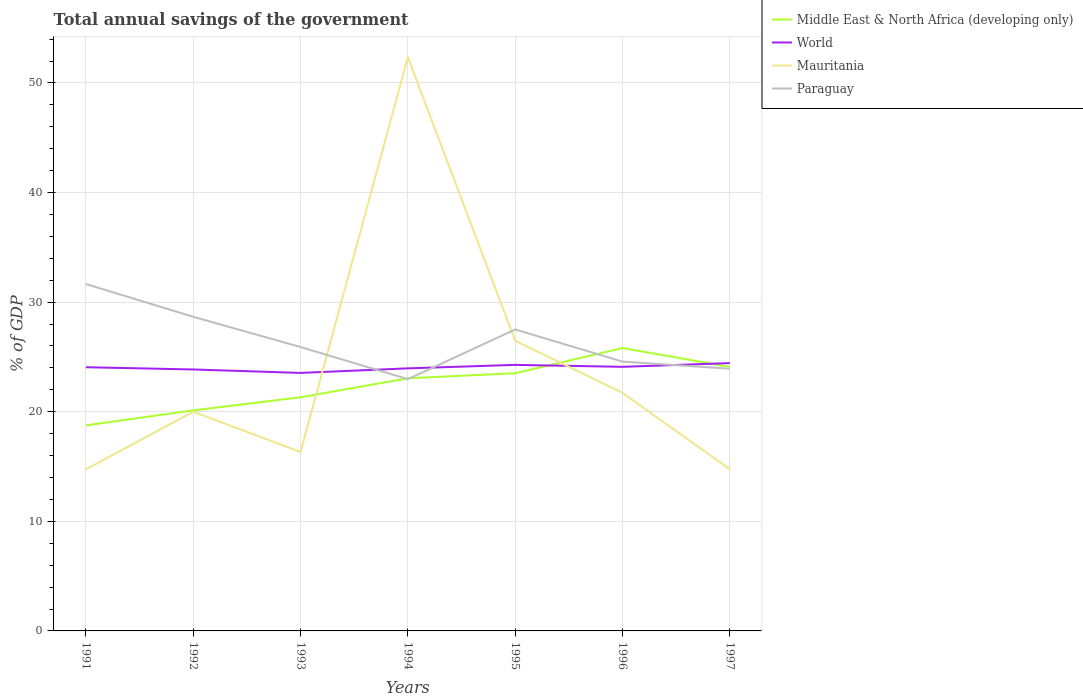Across all years, what is the maximum total annual savings of the government in Paraguay?
Offer a very short reply. 22.97. What is the total total annual savings of the government in Middle East & North Africa (developing only) in the graph?
Keep it short and to the point. -1.19. What is the difference between the highest and the second highest total annual savings of the government in Mauritania?
Provide a succinct answer. 37.61. What is the difference between the highest and the lowest total annual savings of the government in Mauritania?
Give a very brief answer. 2. How many lines are there?
Ensure brevity in your answer.  4. How many years are there in the graph?
Ensure brevity in your answer.  7. What is the difference between two consecutive major ticks on the Y-axis?
Provide a short and direct response. 10. Are the values on the major ticks of Y-axis written in scientific E-notation?
Your answer should be very brief. No. Does the graph contain grids?
Give a very brief answer. Yes. What is the title of the graph?
Your answer should be compact. Total annual savings of the government. What is the label or title of the X-axis?
Ensure brevity in your answer.  Years. What is the label or title of the Y-axis?
Make the answer very short. % of GDP. What is the % of GDP in Middle East & North Africa (developing only) in 1991?
Your answer should be very brief. 18.76. What is the % of GDP of World in 1991?
Give a very brief answer. 24.06. What is the % of GDP in Mauritania in 1991?
Ensure brevity in your answer.  14.74. What is the % of GDP of Paraguay in 1991?
Provide a short and direct response. 31.65. What is the % of GDP of Middle East & North Africa (developing only) in 1992?
Keep it short and to the point. 20.13. What is the % of GDP in World in 1992?
Provide a short and direct response. 23.86. What is the % of GDP in Mauritania in 1992?
Offer a very short reply. 20. What is the % of GDP in Paraguay in 1992?
Offer a very short reply. 28.66. What is the % of GDP in Middle East & North Africa (developing only) in 1993?
Make the answer very short. 21.32. What is the % of GDP of World in 1993?
Keep it short and to the point. 23.54. What is the % of GDP in Mauritania in 1993?
Ensure brevity in your answer.  16.33. What is the % of GDP in Paraguay in 1993?
Your response must be concise. 25.91. What is the % of GDP of Middle East & North Africa (developing only) in 1994?
Your answer should be compact. 23.05. What is the % of GDP of World in 1994?
Keep it short and to the point. 23.96. What is the % of GDP of Mauritania in 1994?
Give a very brief answer. 52.35. What is the % of GDP in Paraguay in 1994?
Make the answer very short. 22.97. What is the % of GDP of Middle East & North Africa (developing only) in 1995?
Keep it short and to the point. 23.51. What is the % of GDP of World in 1995?
Make the answer very short. 24.28. What is the % of GDP of Mauritania in 1995?
Your answer should be very brief. 26.48. What is the % of GDP of Paraguay in 1995?
Make the answer very short. 27.51. What is the % of GDP of Middle East & North Africa (developing only) in 1996?
Give a very brief answer. 25.81. What is the % of GDP of World in 1996?
Keep it short and to the point. 24.1. What is the % of GDP of Mauritania in 1996?
Give a very brief answer. 21.72. What is the % of GDP of Paraguay in 1996?
Offer a very short reply. 24.58. What is the % of GDP in Middle East & North Africa (developing only) in 1997?
Offer a terse response. 24.09. What is the % of GDP of World in 1997?
Give a very brief answer. 24.44. What is the % of GDP in Mauritania in 1997?
Your answer should be compact. 14.76. What is the % of GDP of Paraguay in 1997?
Provide a succinct answer. 23.92. Across all years, what is the maximum % of GDP of Middle East & North Africa (developing only)?
Ensure brevity in your answer.  25.81. Across all years, what is the maximum % of GDP in World?
Provide a succinct answer. 24.44. Across all years, what is the maximum % of GDP in Mauritania?
Your answer should be compact. 52.35. Across all years, what is the maximum % of GDP of Paraguay?
Your response must be concise. 31.65. Across all years, what is the minimum % of GDP in Middle East & North Africa (developing only)?
Offer a very short reply. 18.76. Across all years, what is the minimum % of GDP in World?
Offer a terse response. 23.54. Across all years, what is the minimum % of GDP in Mauritania?
Offer a terse response. 14.74. Across all years, what is the minimum % of GDP in Paraguay?
Give a very brief answer. 22.97. What is the total % of GDP in Middle East & North Africa (developing only) in the graph?
Keep it short and to the point. 156.67. What is the total % of GDP in World in the graph?
Provide a succinct answer. 168.23. What is the total % of GDP of Mauritania in the graph?
Offer a very short reply. 166.38. What is the total % of GDP of Paraguay in the graph?
Provide a short and direct response. 185.2. What is the difference between the % of GDP in Middle East & North Africa (developing only) in 1991 and that in 1992?
Provide a succinct answer. -1.37. What is the difference between the % of GDP in World in 1991 and that in 1992?
Give a very brief answer. 0.21. What is the difference between the % of GDP in Mauritania in 1991 and that in 1992?
Offer a very short reply. -5.26. What is the difference between the % of GDP in Paraguay in 1991 and that in 1992?
Make the answer very short. 2.99. What is the difference between the % of GDP of Middle East & North Africa (developing only) in 1991 and that in 1993?
Your answer should be compact. -2.56. What is the difference between the % of GDP of World in 1991 and that in 1993?
Your response must be concise. 0.52. What is the difference between the % of GDP of Mauritania in 1991 and that in 1993?
Keep it short and to the point. -1.58. What is the difference between the % of GDP in Paraguay in 1991 and that in 1993?
Make the answer very short. 5.75. What is the difference between the % of GDP in Middle East & North Africa (developing only) in 1991 and that in 1994?
Your response must be concise. -4.29. What is the difference between the % of GDP in World in 1991 and that in 1994?
Keep it short and to the point. 0.1. What is the difference between the % of GDP in Mauritania in 1991 and that in 1994?
Ensure brevity in your answer.  -37.61. What is the difference between the % of GDP of Paraguay in 1991 and that in 1994?
Offer a very short reply. 8.68. What is the difference between the % of GDP in Middle East & North Africa (developing only) in 1991 and that in 1995?
Give a very brief answer. -4.75. What is the difference between the % of GDP of World in 1991 and that in 1995?
Make the answer very short. -0.21. What is the difference between the % of GDP of Mauritania in 1991 and that in 1995?
Ensure brevity in your answer.  -11.74. What is the difference between the % of GDP of Paraguay in 1991 and that in 1995?
Your response must be concise. 4.15. What is the difference between the % of GDP in Middle East & North Africa (developing only) in 1991 and that in 1996?
Keep it short and to the point. -7.05. What is the difference between the % of GDP of World in 1991 and that in 1996?
Ensure brevity in your answer.  -0.03. What is the difference between the % of GDP in Mauritania in 1991 and that in 1996?
Your answer should be compact. -6.98. What is the difference between the % of GDP in Paraguay in 1991 and that in 1996?
Provide a succinct answer. 7.08. What is the difference between the % of GDP of Middle East & North Africa (developing only) in 1991 and that in 1997?
Give a very brief answer. -5.33. What is the difference between the % of GDP of World in 1991 and that in 1997?
Offer a terse response. -0.38. What is the difference between the % of GDP of Mauritania in 1991 and that in 1997?
Give a very brief answer. -0.01. What is the difference between the % of GDP in Paraguay in 1991 and that in 1997?
Offer a very short reply. 7.73. What is the difference between the % of GDP in Middle East & North Africa (developing only) in 1992 and that in 1993?
Ensure brevity in your answer.  -1.19. What is the difference between the % of GDP in World in 1992 and that in 1993?
Provide a short and direct response. 0.31. What is the difference between the % of GDP in Mauritania in 1992 and that in 1993?
Your answer should be compact. 3.67. What is the difference between the % of GDP of Paraguay in 1992 and that in 1993?
Make the answer very short. 2.76. What is the difference between the % of GDP in Middle East & North Africa (developing only) in 1992 and that in 1994?
Keep it short and to the point. -2.93. What is the difference between the % of GDP of World in 1992 and that in 1994?
Your answer should be very brief. -0.1. What is the difference between the % of GDP in Mauritania in 1992 and that in 1994?
Provide a succinct answer. -32.35. What is the difference between the % of GDP in Paraguay in 1992 and that in 1994?
Provide a succinct answer. 5.69. What is the difference between the % of GDP of Middle East & North Africa (developing only) in 1992 and that in 1995?
Offer a terse response. -3.39. What is the difference between the % of GDP of World in 1992 and that in 1995?
Provide a succinct answer. -0.42. What is the difference between the % of GDP of Mauritania in 1992 and that in 1995?
Your answer should be very brief. -6.48. What is the difference between the % of GDP in Paraguay in 1992 and that in 1995?
Make the answer very short. 1.16. What is the difference between the % of GDP in Middle East & North Africa (developing only) in 1992 and that in 1996?
Give a very brief answer. -5.68. What is the difference between the % of GDP in World in 1992 and that in 1996?
Keep it short and to the point. -0.24. What is the difference between the % of GDP in Mauritania in 1992 and that in 1996?
Offer a very short reply. -1.72. What is the difference between the % of GDP in Paraguay in 1992 and that in 1996?
Your answer should be compact. 4.09. What is the difference between the % of GDP of Middle East & North Africa (developing only) in 1992 and that in 1997?
Offer a terse response. -3.97. What is the difference between the % of GDP of World in 1992 and that in 1997?
Provide a succinct answer. -0.58. What is the difference between the % of GDP in Mauritania in 1992 and that in 1997?
Your answer should be very brief. 5.24. What is the difference between the % of GDP of Paraguay in 1992 and that in 1997?
Provide a succinct answer. 4.74. What is the difference between the % of GDP in Middle East & North Africa (developing only) in 1993 and that in 1994?
Keep it short and to the point. -1.73. What is the difference between the % of GDP in World in 1993 and that in 1994?
Give a very brief answer. -0.42. What is the difference between the % of GDP in Mauritania in 1993 and that in 1994?
Keep it short and to the point. -36.03. What is the difference between the % of GDP of Paraguay in 1993 and that in 1994?
Your response must be concise. 2.93. What is the difference between the % of GDP of Middle East & North Africa (developing only) in 1993 and that in 1995?
Give a very brief answer. -2.19. What is the difference between the % of GDP of World in 1993 and that in 1995?
Your response must be concise. -0.73. What is the difference between the % of GDP in Mauritania in 1993 and that in 1995?
Provide a succinct answer. -10.16. What is the difference between the % of GDP of Paraguay in 1993 and that in 1995?
Your answer should be compact. -1.6. What is the difference between the % of GDP in Middle East & North Africa (developing only) in 1993 and that in 1996?
Offer a very short reply. -4.49. What is the difference between the % of GDP of World in 1993 and that in 1996?
Your answer should be very brief. -0.55. What is the difference between the % of GDP of Mauritania in 1993 and that in 1996?
Provide a short and direct response. -5.4. What is the difference between the % of GDP of Paraguay in 1993 and that in 1996?
Make the answer very short. 1.33. What is the difference between the % of GDP of Middle East & North Africa (developing only) in 1993 and that in 1997?
Your response must be concise. -2.77. What is the difference between the % of GDP of World in 1993 and that in 1997?
Keep it short and to the point. -0.9. What is the difference between the % of GDP of Mauritania in 1993 and that in 1997?
Ensure brevity in your answer.  1.57. What is the difference between the % of GDP of Paraguay in 1993 and that in 1997?
Your answer should be compact. 1.98. What is the difference between the % of GDP of Middle East & North Africa (developing only) in 1994 and that in 1995?
Offer a very short reply. -0.46. What is the difference between the % of GDP of World in 1994 and that in 1995?
Provide a short and direct response. -0.32. What is the difference between the % of GDP of Mauritania in 1994 and that in 1995?
Offer a terse response. 25.87. What is the difference between the % of GDP in Paraguay in 1994 and that in 1995?
Your answer should be very brief. -4.53. What is the difference between the % of GDP of Middle East & North Africa (developing only) in 1994 and that in 1996?
Provide a succinct answer. -2.76. What is the difference between the % of GDP of World in 1994 and that in 1996?
Provide a succinct answer. -0.14. What is the difference between the % of GDP in Mauritania in 1994 and that in 1996?
Give a very brief answer. 30.63. What is the difference between the % of GDP of Paraguay in 1994 and that in 1996?
Your answer should be compact. -1.6. What is the difference between the % of GDP of Middle East & North Africa (developing only) in 1994 and that in 1997?
Offer a terse response. -1.04. What is the difference between the % of GDP of World in 1994 and that in 1997?
Your answer should be compact. -0.48. What is the difference between the % of GDP of Mauritania in 1994 and that in 1997?
Offer a very short reply. 37.59. What is the difference between the % of GDP in Paraguay in 1994 and that in 1997?
Keep it short and to the point. -0.95. What is the difference between the % of GDP in Middle East & North Africa (developing only) in 1995 and that in 1996?
Ensure brevity in your answer.  -2.3. What is the difference between the % of GDP in World in 1995 and that in 1996?
Provide a succinct answer. 0.18. What is the difference between the % of GDP in Mauritania in 1995 and that in 1996?
Keep it short and to the point. 4.76. What is the difference between the % of GDP of Paraguay in 1995 and that in 1996?
Ensure brevity in your answer.  2.93. What is the difference between the % of GDP of Middle East & North Africa (developing only) in 1995 and that in 1997?
Provide a succinct answer. -0.58. What is the difference between the % of GDP in World in 1995 and that in 1997?
Make the answer very short. -0.16. What is the difference between the % of GDP of Mauritania in 1995 and that in 1997?
Provide a short and direct response. 11.72. What is the difference between the % of GDP of Paraguay in 1995 and that in 1997?
Provide a succinct answer. 3.58. What is the difference between the % of GDP in Middle East & North Africa (developing only) in 1996 and that in 1997?
Provide a short and direct response. 1.72. What is the difference between the % of GDP in World in 1996 and that in 1997?
Provide a short and direct response. -0.34. What is the difference between the % of GDP in Mauritania in 1996 and that in 1997?
Keep it short and to the point. 6.96. What is the difference between the % of GDP of Paraguay in 1996 and that in 1997?
Keep it short and to the point. 0.65. What is the difference between the % of GDP of Middle East & North Africa (developing only) in 1991 and the % of GDP of World in 1992?
Offer a very short reply. -5.1. What is the difference between the % of GDP in Middle East & North Africa (developing only) in 1991 and the % of GDP in Mauritania in 1992?
Provide a short and direct response. -1.24. What is the difference between the % of GDP of Middle East & North Africa (developing only) in 1991 and the % of GDP of Paraguay in 1992?
Offer a very short reply. -9.9. What is the difference between the % of GDP in World in 1991 and the % of GDP in Mauritania in 1992?
Offer a terse response. 4.06. What is the difference between the % of GDP of World in 1991 and the % of GDP of Paraguay in 1992?
Your response must be concise. -4.6. What is the difference between the % of GDP in Mauritania in 1991 and the % of GDP in Paraguay in 1992?
Provide a short and direct response. -13.92. What is the difference between the % of GDP of Middle East & North Africa (developing only) in 1991 and the % of GDP of World in 1993?
Provide a succinct answer. -4.78. What is the difference between the % of GDP of Middle East & North Africa (developing only) in 1991 and the % of GDP of Mauritania in 1993?
Give a very brief answer. 2.43. What is the difference between the % of GDP of Middle East & North Africa (developing only) in 1991 and the % of GDP of Paraguay in 1993?
Offer a very short reply. -7.15. What is the difference between the % of GDP in World in 1991 and the % of GDP in Mauritania in 1993?
Ensure brevity in your answer.  7.74. What is the difference between the % of GDP in World in 1991 and the % of GDP in Paraguay in 1993?
Give a very brief answer. -1.84. What is the difference between the % of GDP of Mauritania in 1991 and the % of GDP of Paraguay in 1993?
Your answer should be very brief. -11.16. What is the difference between the % of GDP in Middle East & North Africa (developing only) in 1991 and the % of GDP in World in 1994?
Ensure brevity in your answer.  -5.2. What is the difference between the % of GDP in Middle East & North Africa (developing only) in 1991 and the % of GDP in Mauritania in 1994?
Your answer should be very brief. -33.59. What is the difference between the % of GDP of Middle East & North Africa (developing only) in 1991 and the % of GDP of Paraguay in 1994?
Your answer should be very brief. -4.22. What is the difference between the % of GDP in World in 1991 and the % of GDP in Mauritania in 1994?
Keep it short and to the point. -28.29. What is the difference between the % of GDP in World in 1991 and the % of GDP in Paraguay in 1994?
Offer a very short reply. 1.09. What is the difference between the % of GDP of Mauritania in 1991 and the % of GDP of Paraguay in 1994?
Keep it short and to the point. -8.23. What is the difference between the % of GDP in Middle East & North Africa (developing only) in 1991 and the % of GDP in World in 1995?
Your response must be concise. -5.52. What is the difference between the % of GDP in Middle East & North Africa (developing only) in 1991 and the % of GDP in Mauritania in 1995?
Make the answer very short. -7.72. What is the difference between the % of GDP in Middle East & North Africa (developing only) in 1991 and the % of GDP in Paraguay in 1995?
Offer a very short reply. -8.75. What is the difference between the % of GDP of World in 1991 and the % of GDP of Mauritania in 1995?
Make the answer very short. -2.42. What is the difference between the % of GDP in World in 1991 and the % of GDP in Paraguay in 1995?
Your answer should be compact. -3.44. What is the difference between the % of GDP in Mauritania in 1991 and the % of GDP in Paraguay in 1995?
Give a very brief answer. -12.76. What is the difference between the % of GDP in Middle East & North Africa (developing only) in 1991 and the % of GDP in World in 1996?
Offer a very short reply. -5.34. What is the difference between the % of GDP in Middle East & North Africa (developing only) in 1991 and the % of GDP in Mauritania in 1996?
Your response must be concise. -2.96. What is the difference between the % of GDP of Middle East & North Africa (developing only) in 1991 and the % of GDP of Paraguay in 1996?
Offer a very short reply. -5.82. What is the difference between the % of GDP of World in 1991 and the % of GDP of Mauritania in 1996?
Ensure brevity in your answer.  2.34. What is the difference between the % of GDP of World in 1991 and the % of GDP of Paraguay in 1996?
Give a very brief answer. -0.51. What is the difference between the % of GDP of Mauritania in 1991 and the % of GDP of Paraguay in 1996?
Give a very brief answer. -9.83. What is the difference between the % of GDP in Middle East & North Africa (developing only) in 1991 and the % of GDP in World in 1997?
Provide a short and direct response. -5.68. What is the difference between the % of GDP of Middle East & North Africa (developing only) in 1991 and the % of GDP of Mauritania in 1997?
Offer a very short reply. 4. What is the difference between the % of GDP in Middle East & North Africa (developing only) in 1991 and the % of GDP in Paraguay in 1997?
Give a very brief answer. -5.16. What is the difference between the % of GDP in World in 1991 and the % of GDP in Mauritania in 1997?
Offer a terse response. 9.3. What is the difference between the % of GDP of World in 1991 and the % of GDP of Paraguay in 1997?
Your answer should be very brief. 0.14. What is the difference between the % of GDP of Mauritania in 1991 and the % of GDP of Paraguay in 1997?
Offer a terse response. -9.18. What is the difference between the % of GDP of Middle East & North Africa (developing only) in 1992 and the % of GDP of World in 1993?
Offer a terse response. -3.42. What is the difference between the % of GDP in Middle East & North Africa (developing only) in 1992 and the % of GDP in Mauritania in 1993?
Offer a terse response. 3.8. What is the difference between the % of GDP of Middle East & North Africa (developing only) in 1992 and the % of GDP of Paraguay in 1993?
Your answer should be very brief. -5.78. What is the difference between the % of GDP of World in 1992 and the % of GDP of Mauritania in 1993?
Your answer should be compact. 7.53. What is the difference between the % of GDP of World in 1992 and the % of GDP of Paraguay in 1993?
Provide a succinct answer. -2.05. What is the difference between the % of GDP of Mauritania in 1992 and the % of GDP of Paraguay in 1993?
Make the answer very short. -5.91. What is the difference between the % of GDP of Middle East & North Africa (developing only) in 1992 and the % of GDP of World in 1994?
Your response must be concise. -3.83. What is the difference between the % of GDP in Middle East & North Africa (developing only) in 1992 and the % of GDP in Mauritania in 1994?
Make the answer very short. -32.23. What is the difference between the % of GDP of Middle East & North Africa (developing only) in 1992 and the % of GDP of Paraguay in 1994?
Provide a short and direct response. -2.85. What is the difference between the % of GDP of World in 1992 and the % of GDP of Mauritania in 1994?
Your response must be concise. -28.5. What is the difference between the % of GDP in World in 1992 and the % of GDP in Paraguay in 1994?
Provide a short and direct response. 0.88. What is the difference between the % of GDP of Mauritania in 1992 and the % of GDP of Paraguay in 1994?
Keep it short and to the point. -2.97. What is the difference between the % of GDP in Middle East & North Africa (developing only) in 1992 and the % of GDP in World in 1995?
Offer a terse response. -4.15. What is the difference between the % of GDP of Middle East & North Africa (developing only) in 1992 and the % of GDP of Mauritania in 1995?
Ensure brevity in your answer.  -6.36. What is the difference between the % of GDP in Middle East & North Africa (developing only) in 1992 and the % of GDP in Paraguay in 1995?
Keep it short and to the point. -7.38. What is the difference between the % of GDP in World in 1992 and the % of GDP in Mauritania in 1995?
Ensure brevity in your answer.  -2.62. What is the difference between the % of GDP of World in 1992 and the % of GDP of Paraguay in 1995?
Your answer should be compact. -3.65. What is the difference between the % of GDP in Mauritania in 1992 and the % of GDP in Paraguay in 1995?
Your answer should be compact. -7.51. What is the difference between the % of GDP of Middle East & North Africa (developing only) in 1992 and the % of GDP of World in 1996?
Provide a succinct answer. -3.97. What is the difference between the % of GDP in Middle East & North Africa (developing only) in 1992 and the % of GDP in Mauritania in 1996?
Give a very brief answer. -1.6. What is the difference between the % of GDP in Middle East & North Africa (developing only) in 1992 and the % of GDP in Paraguay in 1996?
Give a very brief answer. -4.45. What is the difference between the % of GDP in World in 1992 and the % of GDP in Mauritania in 1996?
Your answer should be compact. 2.13. What is the difference between the % of GDP of World in 1992 and the % of GDP of Paraguay in 1996?
Provide a succinct answer. -0.72. What is the difference between the % of GDP in Mauritania in 1992 and the % of GDP in Paraguay in 1996?
Your answer should be compact. -4.57. What is the difference between the % of GDP in Middle East & North Africa (developing only) in 1992 and the % of GDP in World in 1997?
Ensure brevity in your answer.  -4.31. What is the difference between the % of GDP of Middle East & North Africa (developing only) in 1992 and the % of GDP of Mauritania in 1997?
Offer a terse response. 5.37. What is the difference between the % of GDP of Middle East & North Africa (developing only) in 1992 and the % of GDP of Paraguay in 1997?
Your answer should be compact. -3.8. What is the difference between the % of GDP in World in 1992 and the % of GDP in Mauritania in 1997?
Provide a short and direct response. 9.1. What is the difference between the % of GDP in World in 1992 and the % of GDP in Paraguay in 1997?
Ensure brevity in your answer.  -0.07. What is the difference between the % of GDP in Mauritania in 1992 and the % of GDP in Paraguay in 1997?
Your answer should be compact. -3.92. What is the difference between the % of GDP of Middle East & North Africa (developing only) in 1993 and the % of GDP of World in 1994?
Offer a very short reply. -2.64. What is the difference between the % of GDP of Middle East & North Africa (developing only) in 1993 and the % of GDP of Mauritania in 1994?
Give a very brief answer. -31.03. What is the difference between the % of GDP of Middle East & North Africa (developing only) in 1993 and the % of GDP of Paraguay in 1994?
Ensure brevity in your answer.  -1.66. What is the difference between the % of GDP of World in 1993 and the % of GDP of Mauritania in 1994?
Keep it short and to the point. -28.81. What is the difference between the % of GDP in World in 1993 and the % of GDP in Paraguay in 1994?
Offer a very short reply. 0.57. What is the difference between the % of GDP in Mauritania in 1993 and the % of GDP in Paraguay in 1994?
Your answer should be compact. -6.65. What is the difference between the % of GDP of Middle East & North Africa (developing only) in 1993 and the % of GDP of World in 1995?
Your answer should be compact. -2.96. What is the difference between the % of GDP of Middle East & North Africa (developing only) in 1993 and the % of GDP of Mauritania in 1995?
Offer a terse response. -5.16. What is the difference between the % of GDP in Middle East & North Africa (developing only) in 1993 and the % of GDP in Paraguay in 1995?
Offer a terse response. -6.19. What is the difference between the % of GDP in World in 1993 and the % of GDP in Mauritania in 1995?
Give a very brief answer. -2.94. What is the difference between the % of GDP in World in 1993 and the % of GDP in Paraguay in 1995?
Your answer should be compact. -3.96. What is the difference between the % of GDP in Mauritania in 1993 and the % of GDP in Paraguay in 1995?
Ensure brevity in your answer.  -11.18. What is the difference between the % of GDP of Middle East & North Africa (developing only) in 1993 and the % of GDP of World in 1996?
Offer a terse response. -2.78. What is the difference between the % of GDP of Middle East & North Africa (developing only) in 1993 and the % of GDP of Mauritania in 1996?
Offer a terse response. -0.4. What is the difference between the % of GDP of Middle East & North Africa (developing only) in 1993 and the % of GDP of Paraguay in 1996?
Offer a terse response. -3.26. What is the difference between the % of GDP of World in 1993 and the % of GDP of Mauritania in 1996?
Your answer should be very brief. 1.82. What is the difference between the % of GDP of World in 1993 and the % of GDP of Paraguay in 1996?
Make the answer very short. -1.03. What is the difference between the % of GDP in Mauritania in 1993 and the % of GDP in Paraguay in 1996?
Ensure brevity in your answer.  -8.25. What is the difference between the % of GDP of Middle East & North Africa (developing only) in 1993 and the % of GDP of World in 1997?
Your response must be concise. -3.12. What is the difference between the % of GDP of Middle East & North Africa (developing only) in 1993 and the % of GDP of Mauritania in 1997?
Offer a very short reply. 6.56. What is the difference between the % of GDP of Middle East & North Africa (developing only) in 1993 and the % of GDP of Paraguay in 1997?
Keep it short and to the point. -2.6. What is the difference between the % of GDP in World in 1993 and the % of GDP in Mauritania in 1997?
Give a very brief answer. 8.78. What is the difference between the % of GDP of World in 1993 and the % of GDP of Paraguay in 1997?
Ensure brevity in your answer.  -0.38. What is the difference between the % of GDP in Mauritania in 1993 and the % of GDP in Paraguay in 1997?
Make the answer very short. -7.6. What is the difference between the % of GDP in Middle East & North Africa (developing only) in 1994 and the % of GDP in World in 1995?
Offer a very short reply. -1.22. What is the difference between the % of GDP in Middle East & North Africa (developing only) in 1994 and the % of GDP in Mauritania in 1995?
Your answer should be very brief. -3.43. What is the difference between the % of GDP in Middle East & North Africa (developing only) in 1994 and the % of GDP in Paraguay in 1995?
Ensure brevity in your answer.  -4.46. What is the difference between the % of GDP in World in 1994 and the % of GDP in Mauritania in 1995?
Ensure brevity in your answer.  -2.52. What is the difference between the % of GDP of World in 1994 and the % of GDP of Paraguay in 1995?
Give a very brief answer. -3.55. What is the difference between the % of GDP in Mauritania in 1994 and the % of GDP in Paraguay in 1995?
Make the answer very short. 24.85. What is the difference between the % of GDP of Middle East & North Africa (developing only) in 1994 and the % of GDP of World in 1996?
Give a very brief answer. -1.05. What is the difference between the % of GDP of Middle East & North Africa (developing only) in 1994 and the % of GDP of Mauritania in 1996?
Offer a terse response. 1.33. What is the difference between the % of GDP in Middle East & North Africa (developing only) in 1994 and the % of GDP in Paraguay in 1996?
Give a very brief answer. -1.52. What is the difference between the % of GDP of World in 1994 and the % of GDP of Mauritania in 1996?
Your answer should be very brief. 2.24. What is the difference between the % of GDP of World in 1994 and the % of GDP of Paraguay in 1996?
Provide a succinct answer. -0.62. What is the difference between the % of GDP in Mauritania in 1994 and the % of GDP in Paraguay in 1996?
Make the answer very short. 27.78. What is the difference between the % of GDP of Middle East & North Africa (developing only) in 1994 and the % of GDP of World in 1997?
Keep it short and to the point. -1.39. What is the difference between the % of GDP in Middle East & North Africa (developing only) in 1994 and the % of GDP in Mauritania in 1997?
Provide a succinct answer. 8.29. What is the difference between the % of GDP of Middle East & North Africa (developing only) in 1994 and the % of GDP of Paraguay in 1997?
Your response must be concise. -0.87. What is the difference between the % of GDP of World in 1994 and the % of GDP of Mauritania in 1997?
Offer a very short reply. 9.2. What is the difference between the % of GDP of World in 1994 and the % of GDP of Paraguay in 1997?
Offer a very short reply. 0.04. What is the difference between the % of GDP in Mauritania in 1994 and the % of GDP in Paraguay in 1997?
Keep it short and to the point. 28.43. What is the difference between the % of GDP of Middle East & North Africa (developing only) in 1995 and the % of GDP of World in 1996?
Keep it short and to the point. -0.58. What is the difference between the % of GDP of Middle East & North Africa (developing only) in 1995 and the % of GDP of Mauritania in 1996?
Your answer should be very brief. 1.79. What is the difference between the % of GDP of Middle East & North Africa (developing only) in 1995 and the % of GDP of Paraguay in 1996?
Give a very brief answer. -1.06. What is the difference between the % of GDP in World in 1995 and the % of GDP in Mauritania in 1996?
Your response must be concise. 2.55. What is the difference between the % of GDP of World in 1995 and the % of GDP of Paraguay in 1996?
Your answer should be compact. -0.3. What is the difference between the % of GDP in Mauritania in 1995 and the % of GDP in Paraguay in 1996?
Provide a short and direct response. 1.91. What is the difference between the % of GDP in Middle East & North Africa (developing only) in 1995 and the % of GDP in World in 1997?
Make the answer very short. -0.93. What is the difference between the % of GDP in Middle East & North Africa (developing only) in 1995 and the % of GDP in Mauritania in 1997?
Provide a short and direct response. 8.75. What is the difference between the % of GDP in Middle East & North Africa (developing only) in 1995 and the % of GDP in Paraguay in 1997?
Ensure brevity in your answer.  -0.41. What is the difference between the % of GDP of World in 1995 and the % of GDP of Mauritania in 1997?
Make the answer very short. 9.52. What is the difference between the % of GDP in World in 1995 and the % of GDP in Paraguay in 1997?
Offer a very short reply. 0.35. What is the difference between the % of GDP of Mauritania in 1995 and the % of GDP of Paraguay in 1997?
Make the answer very short. 2.56. What is the difference between the % of GDP in Middle East & North Africa (developing only) in 1996 and the % of GDP in World in 1997?
Give a very brief answer. 1.37. What is the difference between the % of GDP of Middle East & North Africa (developing only) in 1996 and the % of GDP of Mauritania in 1997?
Keep it short and to the point. 11.05. What is the difference between the % of GDP in Middle East & North Africa (developing only) in 1996 and the % of GDP in Paraguay in 1997?
Offer a terse response. 1.89. What is the difference between the % of GDP of World in 1996 and the % of GDP of Mauritania in 1997?
Your response must be concise. 9.34. What is the difference between the % of GDP of World in 1996 and the % of GDP of Paraguay in 1997?
Provide a succinct answer. 0.17. What is the difference between the % of GDP of Mauritania in 1996 and the % of GDP of Paraguay in 1997?
Provide a succinct answer. -2.2. What is the average % of GDP of Middle East & North Africa (developing only) per year?
Your answer should be very brief. 22.38. What is the average % of GDP in World per year?
Keep it short and to the point. 24.03. What is the average % of GDP in Mauritania per year?
Offer a terse response. 23.77. What is the average % of GDP in Paraguay per year?
Keep it short and to the point. 26.46. In the year 1991, what is the difference between the % of GDP of Middle East & North Africa (developing only) and % of GDP of World?
Offer a terse response. -5.3. In the year 1991, what is the difference between the % of GDP of Middle East & North Africa (developing only) and % of GDP of Mauritania?
Your answer should be compact. 4.01. In the year 1991, what is the difference between the % of GDP in Middle East & North Africa (developing only) and % of GDP in Paraguay?
Your response must be concise. -12.89. In the year 1991, what is the difference between the % of GDP of World and % of GDP of Mauritania?
Your response must be concise. 9.32. In the year 1991, what is the difference between the % of GDP in World and % of GDP in Paraguay?
Keep it short and to the point. -7.59. In the year 1991, what is the difference between the % of GDP in Mauritania and % of GDP in Paraguay?
Give a very brief answer. -16.91. In the year 1992, what is the difference between the % of GDP in Middle East & North Africa (developing only) and % of GDP in World?
Your answer should be compact. -3.73. In the year 1992, what is the difference between the % of GDP of Middle East & North Africa (developing only) and % of GDP of Mauritania?
Offer a very short reply. 0.13. In the year 1992, what is the difference between the % of GDP of Middle East & North Africa (developing only) and % of GDP of Paraguay?
Offer a terse response. -8.54. In the year 1992, what is the difference between the % of GDP of World and % of GDP of Mauritania?
Keep it short and to the point. 3.86. In the year 1992, what is the difference between the % of GDP in World and % of GDP in Paraguay?
Provide a succinct answer. -4.81. In the year 1992, what is the difference between the % of GDP of Mauritania and % of GDP of Paraguay?
Provide a short and direct response. -8.66. In the year 1993, what is the difference between the % of GDP in Middle East & North Africa (developing only) and % of GDP in World?
Keep it short and to the point. -2.22. In the year 1993, what is the difference between the % of GDP of Middle East & North Africa (developing only) and % of GDP of Mauritania?
Make the answer very short. 4.99. In the year 1993, what is the difference between the % of GDP of Middle East & North Africa (developing only) and % of GDP of Paraguay?
Your answer should be very brief. -4.59. In the year 1993, what is the difference between the % of GDP in World and % of GDP in Mauritania?
Provide a short and direct response. 7.22. In the year 1993, what is the difference between the % of GDP of World and % of GDP of Paraguay?
Your answer should be compact. -2.36. In the year 1993, what is the difference between the % of GDP of Mauritania and % of GDP of Paraguay?
Offer a very short reply. -9.58. In the year 1994, what is the difference between the % of GDP in Middle East & North Africa (developing only) and % of GDP in World?
Your response must be concise. -0.91. In the year 1994, what is the difference between the % of GDP in Middle East & North Africa (developing only) and % of GDP in Mauritania?
Give a very brief answer. -29.3. In the year 1994, what is the difference between the % of GDP in Middle East & North Africa (developing only) and % of GDP in Paraguay?
Keep it short and to the point. 0.08. In the year 1994, what is the difference between the % of GDP in World and % of GDP in Mauritania?
Offer a very short reply. -28.39. In the year 1994, what is the difference between the % of GDP in World and % of GDP in Paraguay?
Keep it short and to the point. 0.98. In the year 1994, what is the difference between the % of GDP of Mauritania and % of GDP of Paraguay?
Your answer should be very brief. 29.38. In the year 1995, what is the difference between the % of GDP of Middle East & North Africa (developing only) and % of GDP of World?
Give a very brief answer. -0.76. In the year 1995, what is the difference between the % of GDP of Middle East & North Africa (developing only) and % of GDP of Mauritania?
Your answer should be compact. -2.97. In the year 1995, what is the difference between the % of GDP of Middle East & North Africa (developing only) and % of GDP of Paraguay?
Offer a terse response. -3.99. In the year 1995, what is the difference between the % of GDP of World and % of GDP of Mauritania?
Your answer should be compact. -2.21. In the year 1995, what is the difference between the % of GDP of World and % of GDP of Paraguay?
Your answer should be compact. -3.23. In the year 1995, what is the difference between the % of GDP in Mauritania and % of GDP in Paraguay?
Provide a short and direct response. -1.03. In the year 1996, what is the difference between the % of GDP of Middle East & North Africa (developing only) and % of GDP of World?
Provide a short and direct response. 1.71. In the year 1996, what is the difference between the % of GDP in Middle East & North Africa (developing only) and % of GDP in Mauritania?
Offer a very short reply. 4.09. In the year 1996, what is the difference between the % of GDP in Middle East & North Africa (developing only) and % of GDP in Paraguay?
Provide a succinct answer. 1.24. In the year 1996, what is the difference between the % of GDP of World and % of GDP of Mauritania?
Your response must be concise. 2.38. In the year 1996, what is the difference between the % of GDP in World and % of GDP in Paraguay?
Your answer should be very brief. -0.48. In the year 1996, what is the difference between the % of GDP in Mauritania and % of GDP in Paraguay?
Provide a short and direct response. -2.85. In the year 1997, what is the difference between the % of GDP in Middle East & North Africa (developing only) and % of GDP in World?
Ensure brevity in your answer.  -0.35. In the year 1997, what is the difference between the % of GDP of Middle East & North Africa (developing only) and % of GDP of Mauritania?
Offer a very short reply. 9.33. In the year 1997, what is the difference between the % of GDP in Middle East & North Africa (developing only) and % of GDP in Paraguay?
Ensure brevity in your answer.  0.17. In the year 1997, what is the difference between the % of GDP in World and % of GDP in Mauritania?
Offer a very short reply. 9.68. In the year 1997, what is the difference between the % of GDP in World and % of GDP in Paraguay?
Keep it short and to the point. 0.51. In the year 1997, what is the difference between the % of GDP in Mauritania and % of GDP in Paraguay?
Provide a succinct answer. -9.17. What is the ratio of the % of GDP of Middle East & North Africa (developing only) in 1991 to that in 1992?
Ensure brevity in your answer.  0.93. What is the ratio of the % of GDP of World in 1991 to that in 1992?
Give a very brief answer. 1.01. What is the ratio of the % of GDP in Mauritania in 1991 to that in 1992?
Make the answer very short. 0.74. What is the ratio of the % of GDP of Paraguay in 1991 to that in 1992?
Provide a succinct answer. 1.1. What is the ratio of the % of GDP of Middle East & North Africa (developing only) in 1991 to that in 1993?
Provide a short and direct response. 0.88. What is the ratio of the % of GDP in World in 1991 to that in 1993?
Your answer should be very brief. 1.02. What is the ratio of the % of GDP in Mauritania in 1991 to that in 1993?
Your answer should be very brief. 0.9. What is the ratio of the % of GDP of Paraguay in 1991 to that in 1993?
Provide a succinct answer. 1.22. What is the ratio of the % of GDP in Middle East & North Africa (developing only) in 1991 to that in 1994?
Offer a terse response. 0.81. What is the ratio of the % of GDP in World in 1991 to that in 1994?
Offer a very short reply. 1. What is the ratio of the % of GDP in Mauritania in 1991 to that in 1994?
Offer a very short reply. 0.28. What is the ratio of the % of GDP in Paraguay in 1991 to that in 1994?
Offer a terse response. 1.38. What is the ratio of the % of GDP of Middle East & North Africa (developing only) in 1991 to that in 1995?
Offer a terse response. 0.8. What is the ratio of the % of GDP in Mauritania in 1991 to that in 1995?
Make the answer very short. 0.56. What is the ratio of the % of GDP in Paraguay in 1991 to that in 1995?
Your answer should be very brief. 1.15. What is the ratio of the % of GDP of Middle East & North Africa (developing only) in 1991 to that in 1996?
Make the answer very short. 0.73. What is the ratio of the % of GDP in Mauritania in 1991 to that in 1996?
Make the answer very short. 0.68. What is the ratio of the % of GDP of Paraguay in 1991 to that in 1996?
Your answer should be compact. 1.29. What is the ratio of the % of GDP in Middle East & North Africa (developing only) in 1991 to that in 1997?
Ensure brevity in your answer.  0.78. What is the ratio of the % of GDP of World in 1991 to that in 1997?
Ensure brevity in your answer.  0.98. What is the ratio of the % of GDP in Mauritania in 1991 to that in 1997?
Offer a very short reply. 1. What is the ratio of the % of GDP in Paraguay in 1991 to that in 1997?
Give a very brief answer. 1.32. What is the ratio of the % of GDP in Middle East & North Africa (developing only) in 1992 to that in 1993?
Make the answer very short. 0.94. What is the ratio of the % of GDP in World in 1992 to that in 1993?
Make the answer very short. 1.01. What is the ratio of the % of GDP of Mauritania in 1992 to that in 1993?
Provide a succinct answer. 1.23. What is the ratio of the % of GDP of Paraguay in 1992 to that in 1993?
Your response must be concise. 1.11. What is the ratio of the % of GDP of Middle East & North Africa (developing only) in 1992 to that in 1994?
Give a very brief answer. 0.87. What is the ratio of the % of GDP of World in 1992 to that in 1994?
Your answer should be very brief. 1. What is the ratio of the % of GDP in Mauritania in 1992 to that in 1994?
Make the answer very short. 0.38. What is the ratio of the % of GDP of Paraguay in 1992 to that in 1994?
Provide a short and direct response. 1.25. What is the ratio of the % of GDP of Middle East & North Africa (developing only) in 1992 to that in 1995?
Provide a succinct answer. 0.86. What is the ratio of the % of GDP in World in 1992 to that in 1995?
Your response must be concise. 0.98. What is the ratio of the % of GDP of Mauritania in 1992 to that in 1995?
Your answer should be very brief. 0.76. What is the ratio of the % of GDP of Paraguay in 1992 to that in 1995?
Make the answer very short. 1.04. What is the ratio of the % of GDP of Middle East & North Africa (developing only) in 1992 to that in 1996?
Provide a succinct answer. 0.78. What is the ratio of the % of GDP of World in 1992 to that in 1996?
Keep it short and to the point. 0.99. What is the ratio of the % of GDP in Mauritania in 1992 to that in 1996?
Keep it short and to the point. 0.92. What is the ratio of the % of GDP of Paraguay in 1992 to that in 1996?
Ensure brevity in your answer.  1.17. What is the ratio of the % of GDP of Middle East & North Africa (developing only) in 1992 to that in 1997?
Ensure brevity in your answer.  0.84. What is the ratio of the % of GDP in World in 1992 to that in 1997?
Make the answer very short. 0.98. What is the ratio of the % of GDP of Mauritania in 1992 to that in 1997?
Your response must be concise. 1.36. What is the ratio of the % of GDP of Paraguay in 1992 to that in 1997?
Your response must be concise. 1.2. What is the ratio of the % of GDP of Middle East & North Africa (developing only) in 1993 to that in 1994?
Make the answer very short. 0.92. What is the ratio of the % of GDP of World in 1993 to that in 1994?
Make the answer very short. 0.98. What is the ratio of the % of GDP of Mauritania in 1993 to that in 1994?
Provide a short and direct response. 0.31. What is the ratio of the % of GDP in Paraguay in 1993 to that in 1994?
Provide a succinct answer. 1.13. What is the ratio of the % of GDP in Middle East & North Africa (developing only) in 1993 to that in 1995?
Provide a succinct answer. 0.91. What is the ratio of the % of GDP of World in 1993 to that in 1995?
Keep it short and to the point. 0.97. What is the ratio of the % of GDP in Mauritania in 1993 to that in 1995?
Ensure brevity in your answer.  0.62. What is the ratio of the % of GDP of Paraguay in 1993 to that in 1995?
Offer a terse response. 0.94. What is the ratio of the % of GDP in Middle East & North Africa (developing only) in 1993 to that in 1996?
Make the answer very short. 0.83. What is the ratio of the % of GDP of World in 1993 to that in 1996?
Your response must be concise. 0.98. What is the ratio of the % of GDP in Mauritania in 1993 to that in 1996?
Ensure brevity in your answer.  0.75. What is the ratio of the % of GDP of Paraguay in 1993 to that in 1996?
Your answer should be very brief. 1.05. What is the ratio of the % of GDP of Middle East & North Africa (developing only) in 1993 to that in 1997?
Your response must be concise. 0.89. What is the ratio of the % of GDP in World in 1993 to that in 1997?
Provide a succinct answer. 0.96. What is the ratio of the % of GDP of Mauritania in 1993 to that in 1997?
Give a very brief answer. 1.11. What is the ratio of the % of GDP in Paraguay in 1993 to that in 1997?
Give a very brief answer. 1.08. What is the ratio of the % of GDP of Middle East & North Africa (developing only) in 1994 to that in 1995?
Ensure brevity in your answer.  0.98. What is the ratio of the % of GDP in Mauritania in 1994 to that in 1995?
Make the answer very short. 1.98. What is the ratio of the % of GDP of Paraguay in 1994 to that in 1995?
Your answer should be compact. 0.84. What is the ratio of the % of GDP of Middle East & North Africa (developing only) in 1994 to that in 1996?
Provide a short and direct response. 0.89. What is the ratio of the % of GDP in Mauritania in 1994 to that in 1996?
Give a very brief answer. 2.41. What is the ratio of the % of GDP in Paraguay in 1994 to that in 1996?
Your answer should be very brief. 0.93. What is the ratio of the % of GDP of Middle East & North Africa (developing only) in 1994 to that in 1997?
Your answer should be very brief. 0.96. What is the ratio of the % of GDP of World in 1994 to that in 1997?
Offer a terse response. 0.98. What is the ratio of the % of GDP in Mauritania in 1994 to that in 1997?
Offer a very short reply. 3.55. What is the ratio of the % of GDP of Paraguay in 1994 to that in 1997?
Make the answer very short. 0.96. What is the ratio of the % of GDP of Middle East & North Africa (developing only) in 1995 to that in 1996?
Ensure brevity in your answer.  0.91. What is the ratio of the % of GDP of World in 1995 to that in 1996?
Your answer should be very brief. 1.01. What is the ratio of the % of GDP of Mauritania in 1995 to that in 1996?
Your response must be concise. 1.22. What is the ratio of the % of GDP of Paraguay in 1995 to that in 1996?
Keep it short and to the point. 1.12. What is the ratio of the % of GDP of Mauritania in 1995 to that in 1997?
Keep it short and to the point. 1.79. What is the ratio of the % of GDP of Paraguay in 1995 to that in 1997?
Your answer should be compact. 1.15. What is the ratio of the % of GDP in Middle East & North Africa (developing only) in 1996 to that in 1997?
Your response must be concise. 1.07. What is the ratio of the % of GDP in Mauritania in 1996 to that in 1997?
Your answer should be very brief. 1.47. What is the ratio of the % of GDP of Paraguay in 1996 to that in 1997?
Your answer should be very brief. 1.03. What is the difference between the highest and the second highest % of GDP in Middle East & North Africa (developing only)?
Your answer should be compact. 1.72. What is the difference between the highest and the second highest % of GDP in World?
Provide a short and direct response. 0.16. What is the difference between the highest and the second highest % of GDP in Mauritania?
Your answer should be compact. 25.87. What is the difference between the highest and the second highest % of GDP of Paraguay?
Offer a terse response. 2.99. What is the difference between the highest and the lowest % of GDP in Middle East & North Africa (developing only)?
Provide a succinct answer. 7.05. What is the difference between the highest and the lowest % of GDP of World?
Your answer should be very brief. 0.9. What is the difference between the highest and the lowest % of GDP in Mauritania?
Provide a succinct answer. 37.61. What is the difference between the highest and the lowest % of GDP in Paraguay?
Keep it short and to the point. 8.68. 